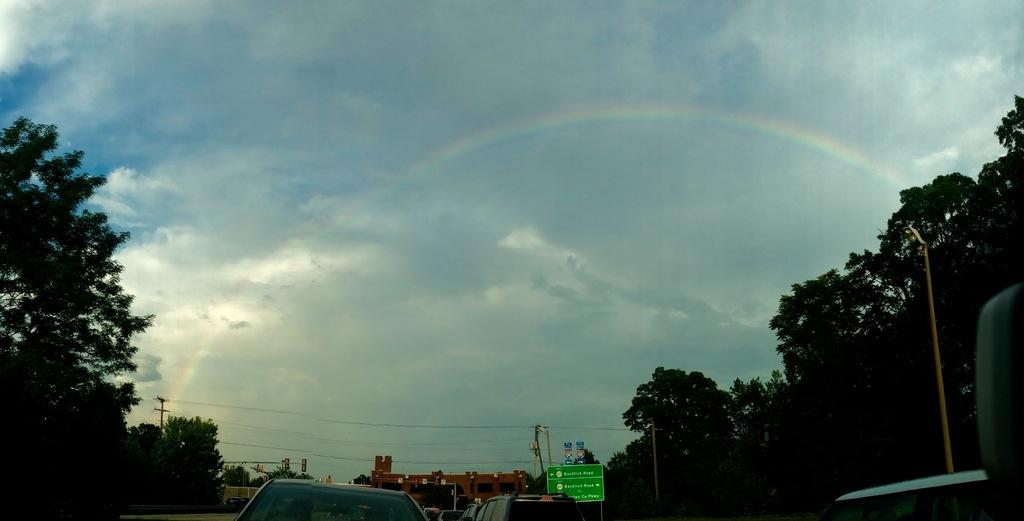What type of structures can be seen in the image? There are buildings in the image. What else is visible besides buildings? There are vehicles, trees, current poles, a board with text, and a street light in the image. Can you describe the natural elements in the image? There are trees at the side of the image. What is visible in the sky in the image? The sky is visible in the image. What type of drum can be heard playing in the image? There is no drum or sound present in the image; it is a still image. 